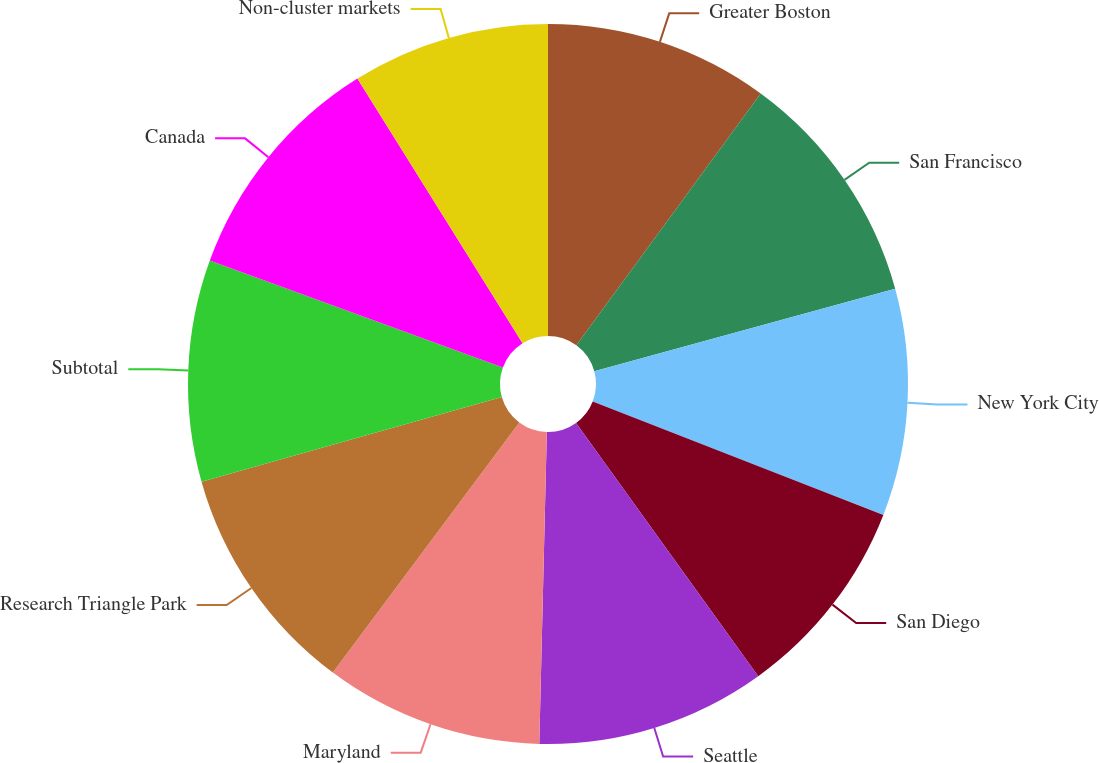Convert chart. <chart><loc_0><loc_0><loc_500><loc_500><pie_chart><fcel>Greater Boston<fcel>San Francisco<fcel>New York City<fcel>San Diego<fcel>Seattle<fcel>Maryland<fcel>Research Triangle Park<fcel>Subtotal<fcel>Canada<fcel>Non-cluster markets<nl><fcel>10.06%<fcel>10.68%<fcel>10.18%<fcel>9.15%<fcel>10.31%<fcel>9.81%<fcel>10.43%<fcel>9.94%<fcel>10.55%<fcel>8.88%<nl></chart> 